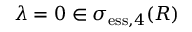<formula> <loc_0><loc_0><loc_500><loc_500>\lambda = 0 \in \sigma _ { e s s , 4 } ( R )</formula> 